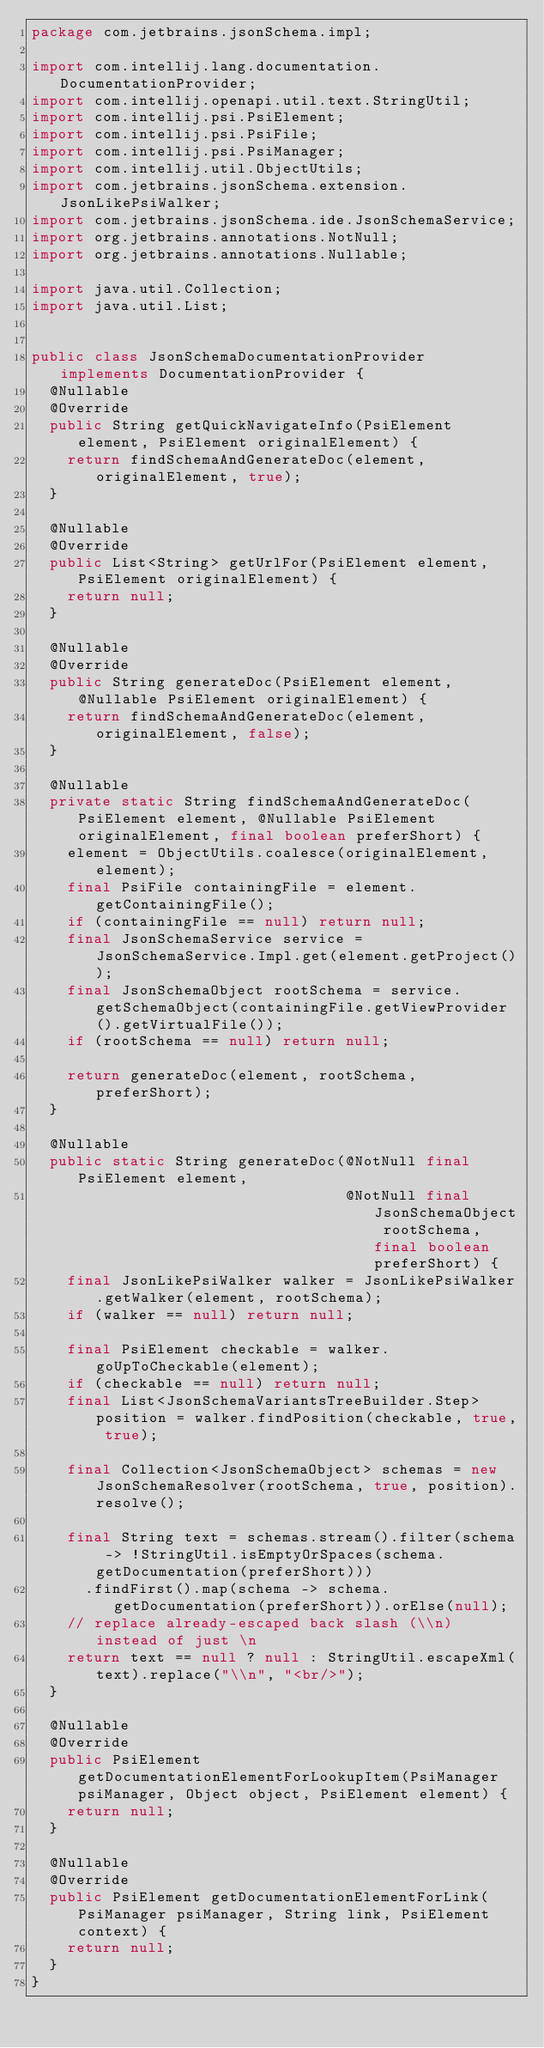Convert code to text. <code><loc_0><loc_0><loc_500><loc_500><_Java_>package com.jetbrains.jsonSchema.impl;

import com.intellij.lang.documentation.DocumentationProvider;
import com.intellij.openapi.util.text.StringUtil;
import com.intellij.psi.PsiElement;
import com.intellij.psi.PsiFile;
import com.intellij.psi.PsiManager;
import com.intellij.util.ObjectUtils;
import com.jetbrains.jsonSchema.extension.JsonLikePsiWalker;
import com.jetbrains.jsonSchema.ide.JsonSchemaService;
import org.jetbrains.annotations.NotNull;
import org.jetbrains.annotations.Nullable;

import java.util.Collection;
import java.util.List;


public class JsonSchemaDocumentationProvider implements DocumentationProvider {
  @Nullable
  @Override
  public String getQuickNavigateInfo(PsiElement element, PsiElement originalElement) {
    return findSchemaAndGenerateDoc(element, originalElement, true);
  }

  @Nullable
  @Override
  public List<String> getUrlFor(PsiElement element, PsiElement originalElement) {
    return null;
  }

  @Nullable
  @Override
  public String generateDoc(PsiElement element, @Nullable PsiElement originalElement) {
    return findSchemaAndGenerateDoc(element, originalElement, false);
  }

  @Nullable
  private static String findSchemaAndGenerateDoc(PsiElement element, @Nullable PsiElement originalElement, final boolean preferShort) {
    element = ObjectUtils.coalesce(originalElement, element);
    final PsiFile containingFile = element.getContainingFile();
    if (containingFile == null) return null;
    final JsonSchemaService service = JsonSchemaService.Impl.get(element.getProject());
    final JsonSchemaObject rootSchema = service.getSchemaObject(containingFile.getViewProvider().getVirtualFile());
    if (rootSchema == null) return null;

    return generateDoc(element, rootSchema, preferShort);
  }

  @Nullable
  public static String generateDoc(@NotNull final PsiElement element,
                                   @NotNull final JsonSchemaObject rootSchema, final boolean preferShort) {
    final JsonLikePsiWalker walker = JsonLikePsiWalker.getWalker(element, rootSchema);
    if (walker == null) return null;

    final PsiElement checkable = walker.goUpToCheckable(element);
    if (checkable == null) return null;
    final List<JsonSchemaVariantsTreeBuilder.Step> position = walker.findPosition(checkable, true, true);

    final Collection<JsonSchemaObject> schemas = new JsonSchemaResolver(rootSchema, true, position).resolve();

    final String text = schemas.stream().filter(schema -> !StringUtil.isEmptyOrSpaces(schema.getDocumentation(preferShort)))
      .findFirst().map(schema -> schema.getDocumentation(preferShort)).orElse(null);
    // replace already-escaped back slash (\\n) instead of just \n
    return text == null ? null : StringUtil.escapeXml(text).replace("\\n", "<br/>");
  }

  @Nullable
  @Override
  public PsiElement getDocumentationElementForLookupItem(PsiManager psiManager, Object object, PsiElement element) {
    return null;
  }

  @Nullable
  @Override
  public PsiElement getDocumentationElementForLink(PsiManager psiManager, String link, PsiElement context) {
    return null;
  }
}
</code> 